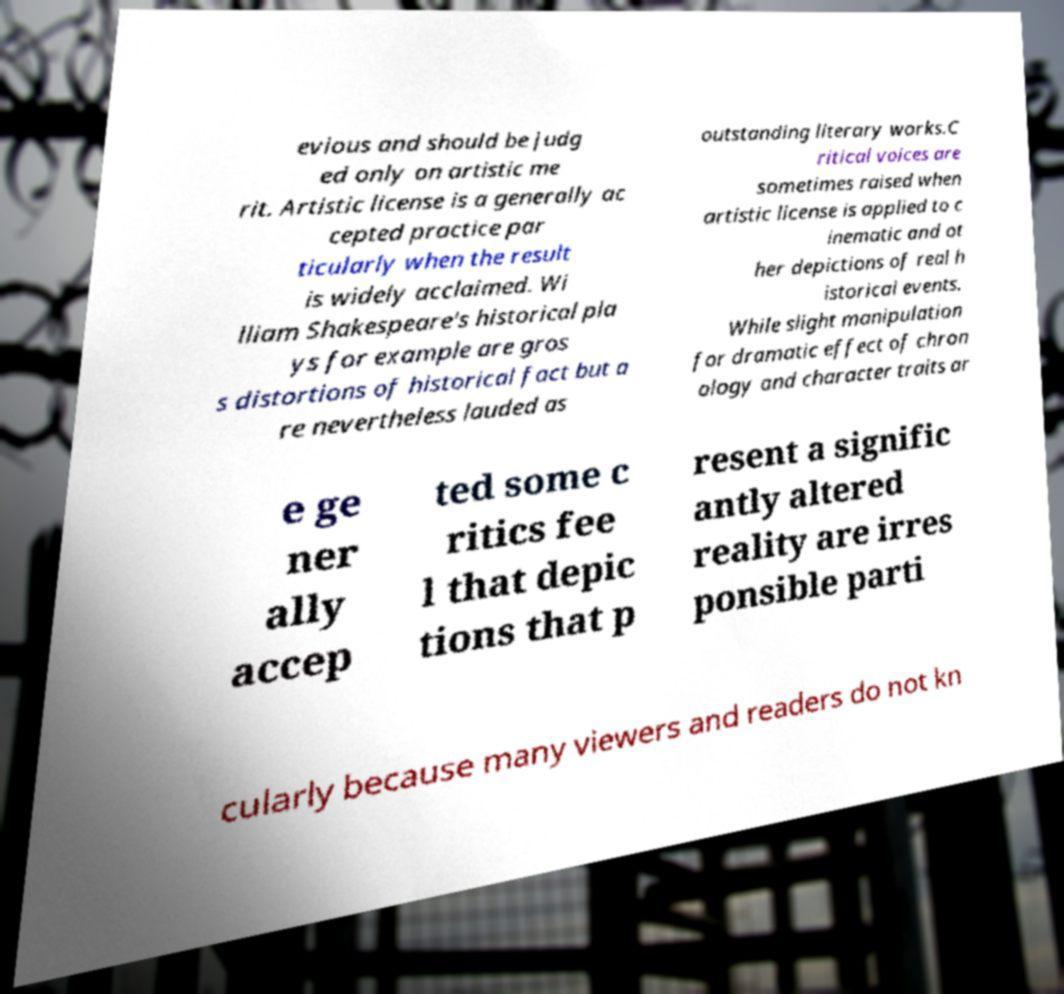Please identify and transcribe the text found in this image. evious and should be judg ed only on artistic me rit. Artistic license is a generally ac cepted practice par ticularly when the result is widely acclaimed. Wi lliam Shakespeare's historical pla ys for example are gros s distortions of historical fact but a re nevertheless lauded as outstanding literary works.C ritical voices are sometimes raised when artistic license is applied to c inematic and ot her depictions of real h istorical events. While slight manipulation for dramatic effect of chron ology and character traits ar e ge ner ally accep ted some c ritics fee l that depic tions that p resent a signific antly altered reality are irres ponsible parti cularly because many viewers and readers do not kn 